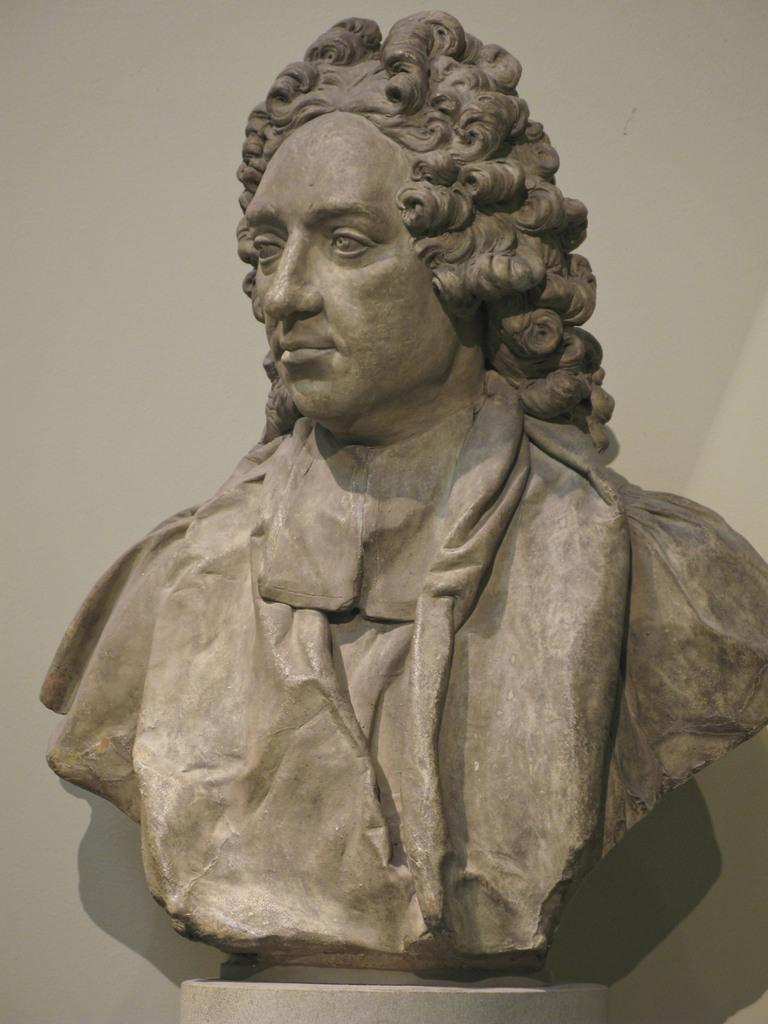What is the main subject of the image? There is a statue in the image. Can you describe the statue? The statue is of a man. What type of stick is the man holding in the image? There is no stick present in the image; the statue is of a man without any objects. 